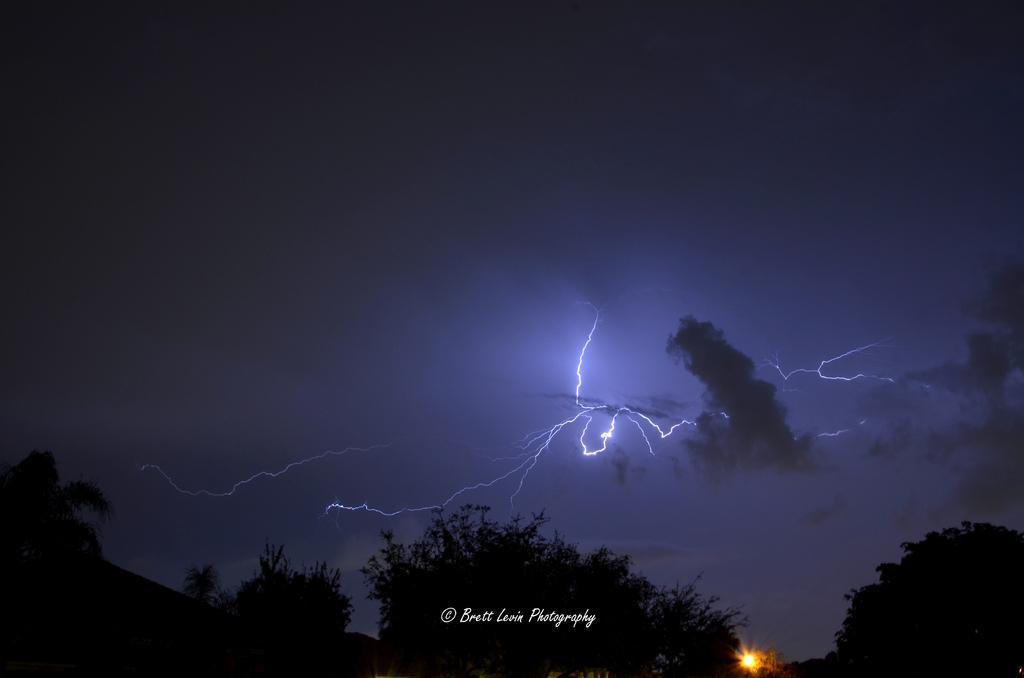In one or two sentences, can you explain what this image depicts? In the picture we can see some trees in the dark and behind it, we can see a sky with thunderstorms and clouds. 